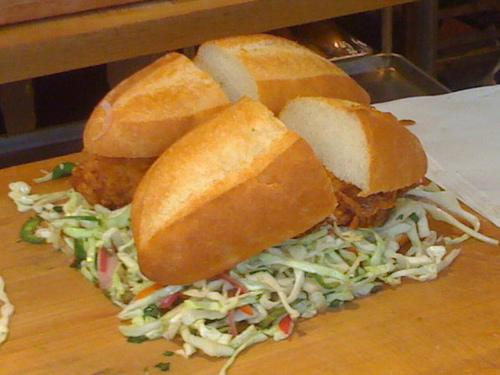Question: what kind of bread is it?
Choices:
A. French.
B. Wheat.
C. Italian.
D. Rye.
Answer with the letter. Answer: C Question: how many sandwiches are there?
Choices:
A. 2.
B. 4.
C. 6.
D. 8.
Answer with the letter. Answer: A Question: what is on cutting board around sandwiches?
Choices:
A. Ham.
B. Cheese.
C. Sliced lettuce and vegetables.
D. Mustard.
Answer with the letter. Answer: C Question: how many pieces are subs cut into?
Choices:
A. 1.
B. 3.
C. 6.
D. 4.
Answer with the letter. Answer: D Question: what is lying on cutting board behind subs?
Choices:
A. Knife.
B. Bread.
C. White cloth.
D. Meat.
Answer with the letter. Answer: C 